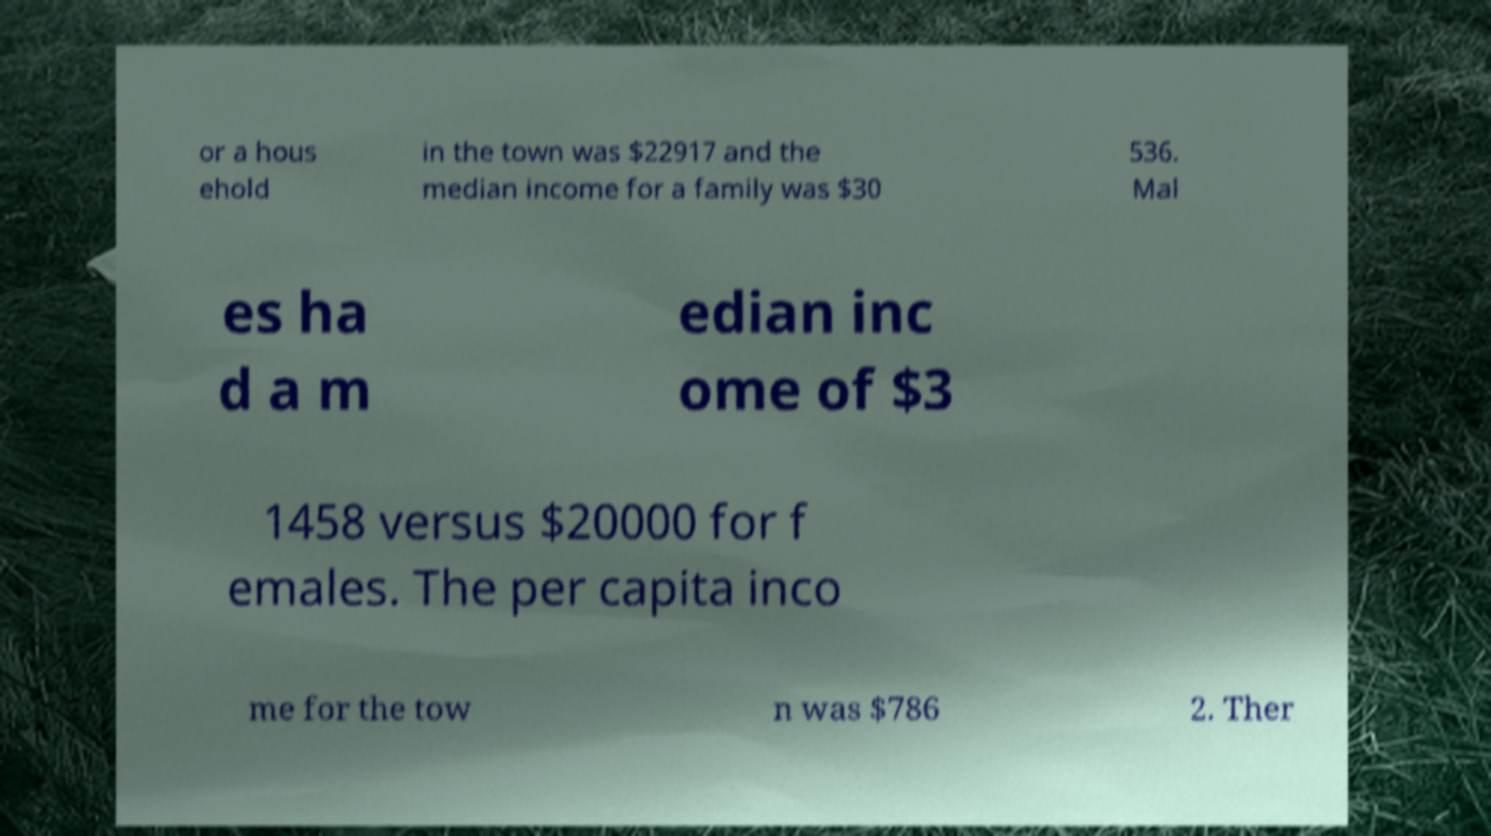Can you accurately transcribe the text from the provided image for me? or a hous ehold in the town was $22917 and the median income for a family was $30 536. Mal es ha d a m edian inc ome of $3 1458 versus $20000 for f emales. The per capita inco me for the tow n was $786 2. Ther 